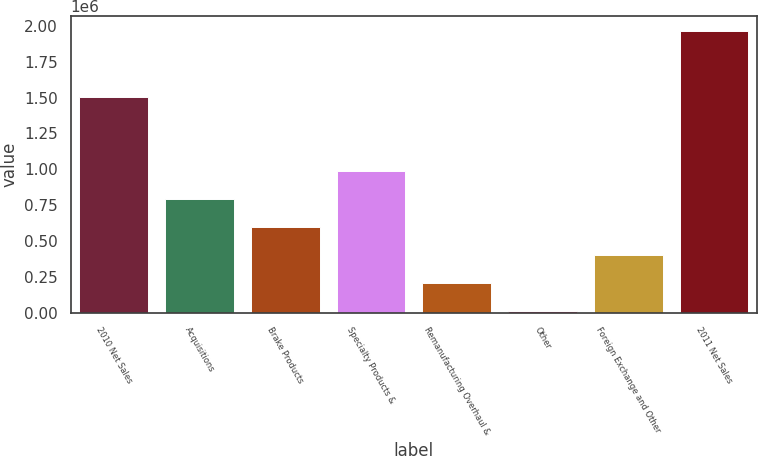<chart> <loc_0><loc_0><loc_500><loc_500><bar_chart><fcel>2010 Net Sales<fcel>Acquisitions<fcel>Brake Products<fcel>Specialty Products &<fcel>Remanufacturing Overhaul &<fcel>Other<fcel>Foreign Exchange and Other<fcel>2011 Net Sales<nl><fcel>1.50701e+06<fcel>792530<fcel>596679<fcel>988382<fcel>204977<fcel>9126<fcel>400828<fcel>1.96764e+06<nl></chart> 